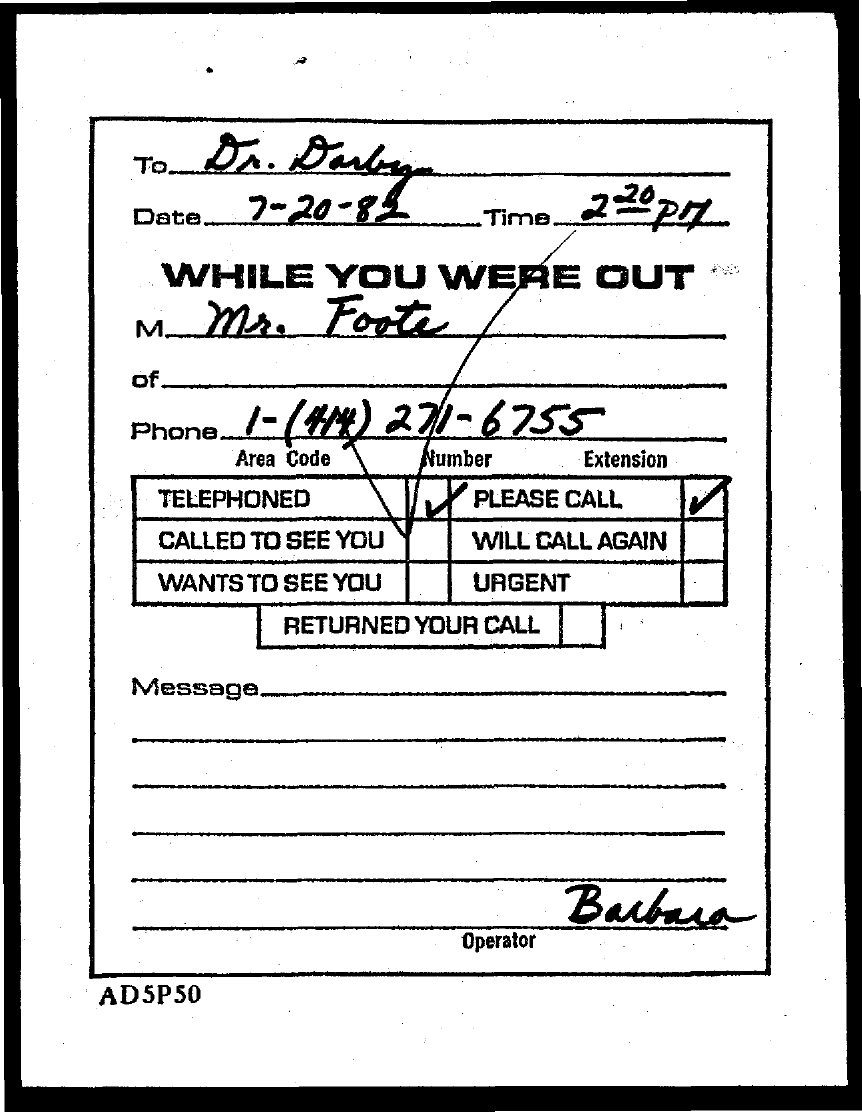Draw attention to some important aspects in this diagram. The document contains the date of July 20, 1982. The phone number is 1-(414) 271-6755. 